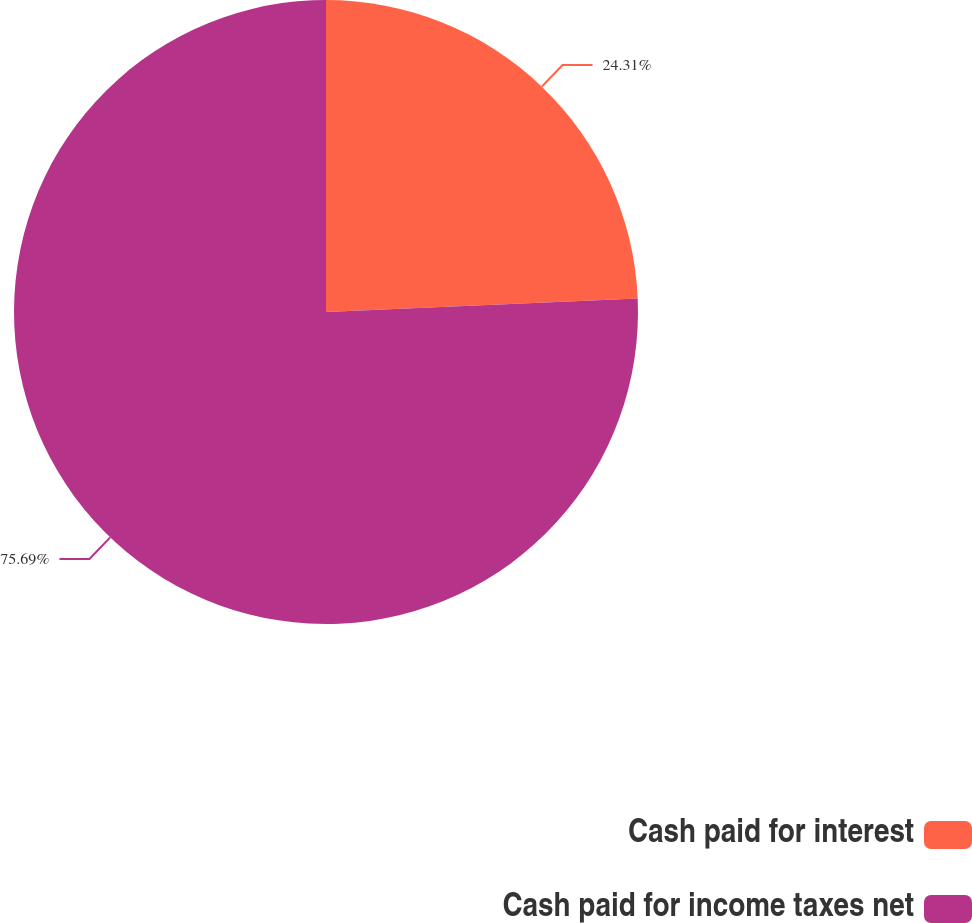<chart> <loc_0><loc_0><loc_500><loc_500><pie_chart><fcel>Cash paid for interest<fcel>Cash paid for income taxes net<nl><fcel>24.31%<fcel>75.69%<nl></chart> 